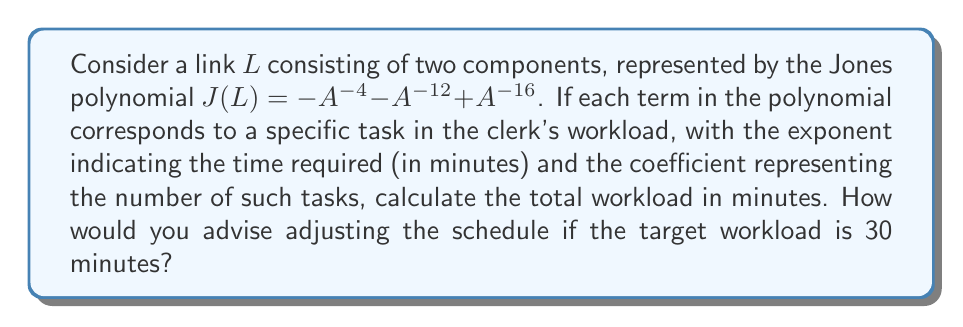Can you solve this math problem? 1) First, let's identify the terms in the Jones polynomial:
   $J(L) = -A^{-4} - A^{-12} + A^{-16}$

2) Interpret each term:
   - $-A^{-4}$: 1 task taking 4 minutes
   - $-A^{-12}$: 1 task taking 12 minutes
   - $+A^{-16}$: 1 task taking 16 minutes

3) Calculate the total workload:
   Total time = $|(-1) \cdot 4| + |(-1) \cdot 12| + |(1) \cdot 16|$
               = $4 + 12 + 16$
               = $32$ minutes

4) Compare with the target workload:
   Current workload: 32 minutes
   Target workload: 30 minutes
   Difference: 32 - 30 = 2 minutes over

5) Advice for adjusting the schedule:
   To reduce the workload by 2 minutes, consider:
   a) Optimizing the 4-minute task to save 2 minutes, or
   b) Slightly reducing the time allocated for the 12-minute or 16-minute task
Answer: 32 minutes; optimize 4-minute task or reduce time for longer tasks 